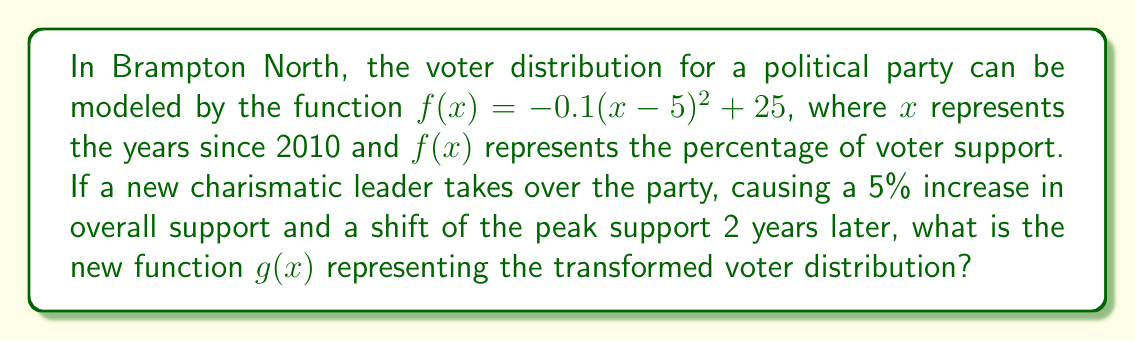Help me with this question. 1. The original function is $f(x) = -0.1(x-5)^2 + 25$

2. A 5% increase in overall support is a vertical shift upward:
   $f(x) + 5$

3. A shift of the peak support 2 years later is a horizontal shift to the right:
   $f(x-2)$

4. Combining these transformations:
   $g(x) = f(x-2) + 5$

5. Substituting the original function:
   $g(x) = -0.1((x-2)-5)^2 + 25 + 5$

6. Simplifying:
   $g(x) = -0.1(x-7)^2 + 30$

Therefore, the new function representing the transformed voter distribution is $g(x) = -0.1(x-7)^2 + 30$.
Answer: $g(x) = -0.1(x-7)^2 + 30$ 